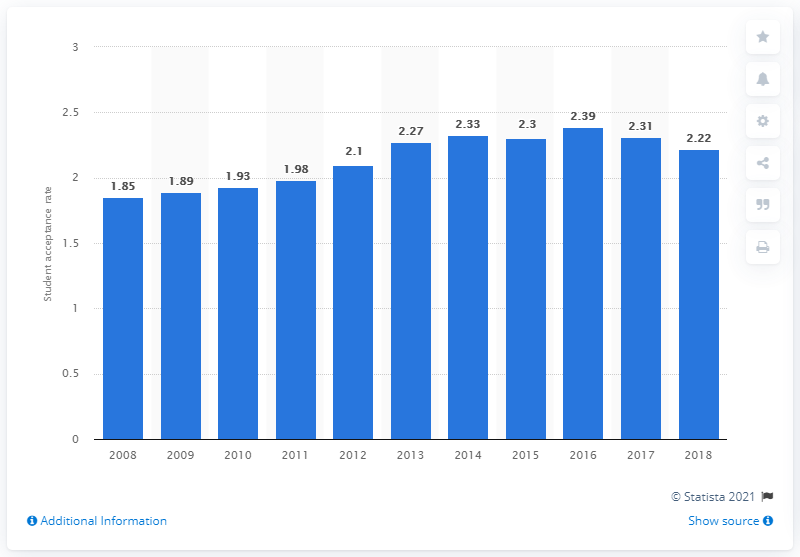Specify some key components in this picture. In 2016, Sweden's highest student acceptance rate was 2.39. In 2018, the student acceptance rate in Sweden was 2.22. 